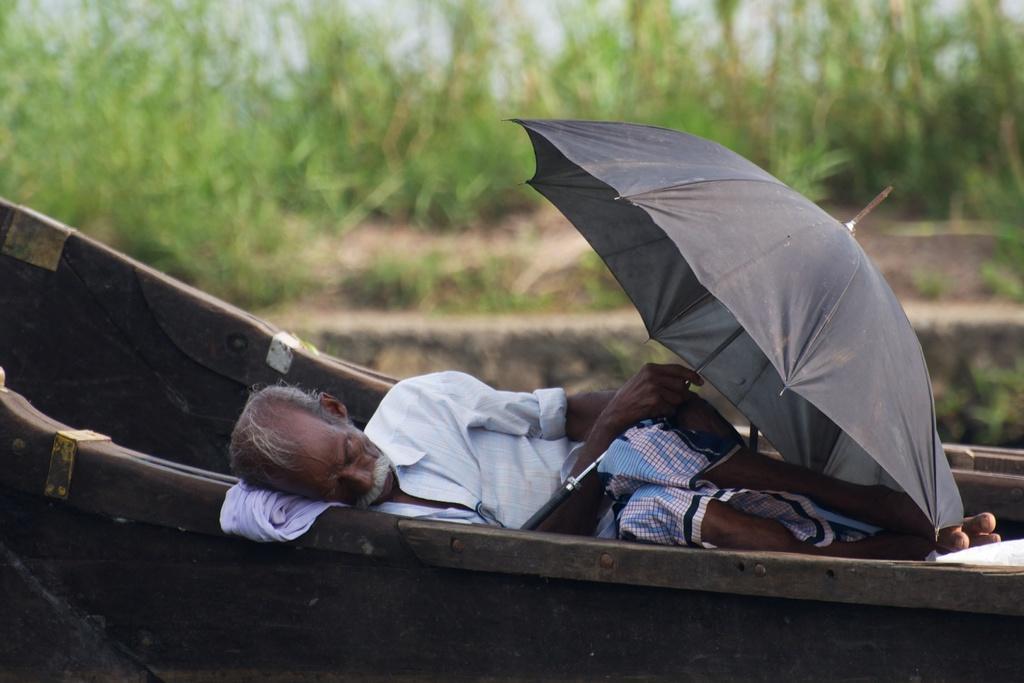How would you summarize this image in a sentence or two? In this image we can see a man lying on the boat and he is holding an umbrella and in the background, we can see some plants and the image is blurred. 